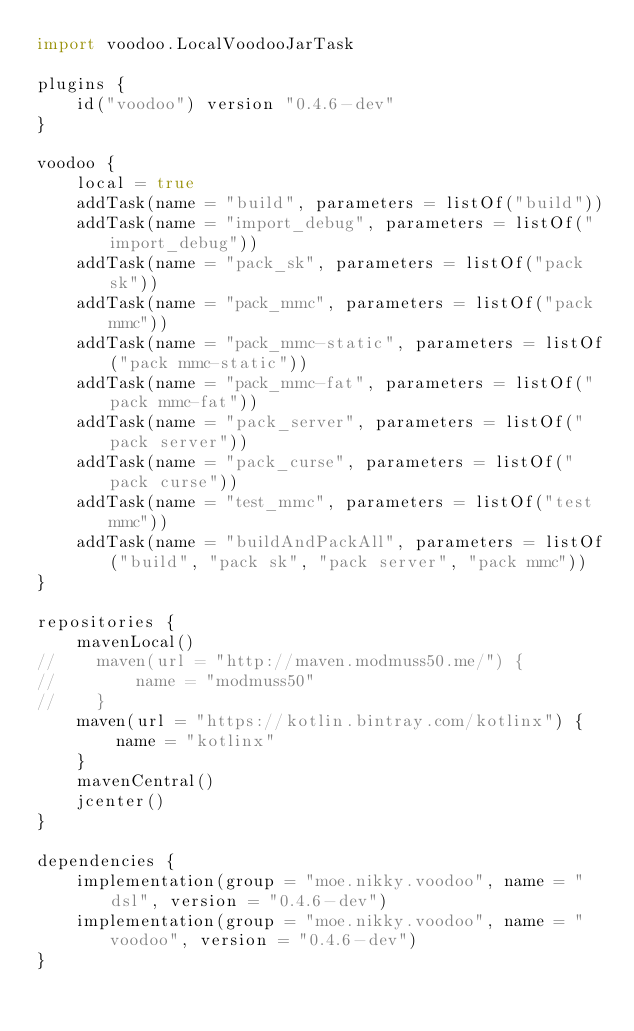<code> <loc_0><loc_0><loc_500><loc_500><_Kotlin_>import voodoo.LocalVoodooJarTask

plugins {
    id("voodoo") version "0.4.6-dev"
}

voodoo {
    local = true
    addTask(name = "build", parameters = listOf("build"))
    addTask(name = "import_debug", parameters = listOf("import_debug"))
    addTask(name = "pack_sk", parameters = listOf("pack sk"))
    addTask(name = "pack_mmc", parameters = listOf("pack mmc"))
    addTask(name = "pack_mmc-static", parameters = listOf("pack mmc-static"))
    addTask(name = "pack_mmc-fat", parameters = listOf("pack mmc-fat"))
    addTask(name = "pack_server", parameters = listOf("pack server"))
    addTask(name = "pack_curse", parameters = listOf("pack curse"))
    addTask(name = "test_mmc", parameters = listOf("test mmc"))
    addTask(name = "buildAndPackAll", parameters = listOf("build", "pack sk", "pack server", "pack mmc"))
}

repositories {
    mavenLocal()
//    maven(url = "http://maven.modmuss50.me/") {
//        name = "modmuss50"
//    }
    maven(url = "https://kotlin.bintray.com/kotlinx") {
        name = "kotlinx"
    }
    mavenCentral()
    jcenter()
}

dependencies {
    implementation(group = "moe.nikky.voodoo", name = "dsl", version = "0.4.6-dev")
    implementation(group = "moe.nikky.voodoo", name = "voodoo", version = "0.4.6-dev")
}
</code> 